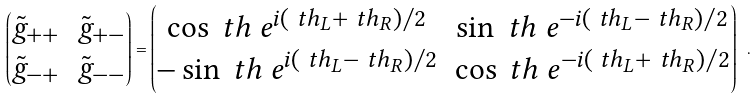Convert formula to latex. <formula><loc_0><loc_0><loc_500><loc_500>\begin{pmatrix} \tilde { g } _ { + + } & \tilde { g } _ { + - } \\ \tilde { g } _ { - + } & \tilde { g } _ { - - } \end{pmatrix} = \begin{pmatrix} \cos \ t h \ e ^ { i ( \ t h _ { L } + \ t h _ { R } ) / 2 } & \sin \ t h \ e ^ { - i ( \ t h _ { L } - \ t h _ { R } ) / 2 } \\ - \sin \ t h \ e ^ { i ( \ t h _ { L } - \ t h _ { R } ) / 2 } & \cos \ t h \ e ^ { - i ( \ t h _ { L } + \ t h _ { R } ) / 2 } \end{pmatrix} \ .</formula> 